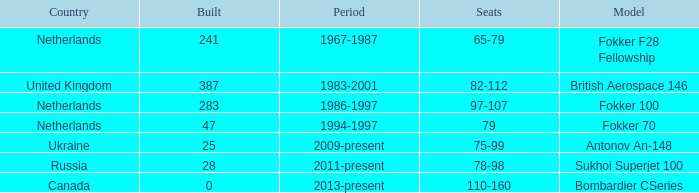During which years were 241 fokker 70 model cabins assembled? 1994-1997. Can you parse all the data within this table? {'header': ['Country', 'Built', 'Period', 'Seats', 'Model'], 'rows': [['Netherlands', '241', '1967-1987', '65-79', 'Fokker F28 Fellowship'], ['United Kingdom', '387', '1983-2001', '82-112', 'British Aerospace 146'], ['Netherlands', '283', '1986-1997', '97-107', 'Fokker 100'], ['Netherlands', '47', '1994-1997', '79', 'Fokker 70'], ['Ukraine', '25', '2009-present', '75-99', 'Antonov An-148'], ['Russia', '28', '2011-present', '78-98', 'Sukhoi Superjet 100'], ['Canada', '0', '2013-present', '110-160', 'Bombardier CSeries']]} 